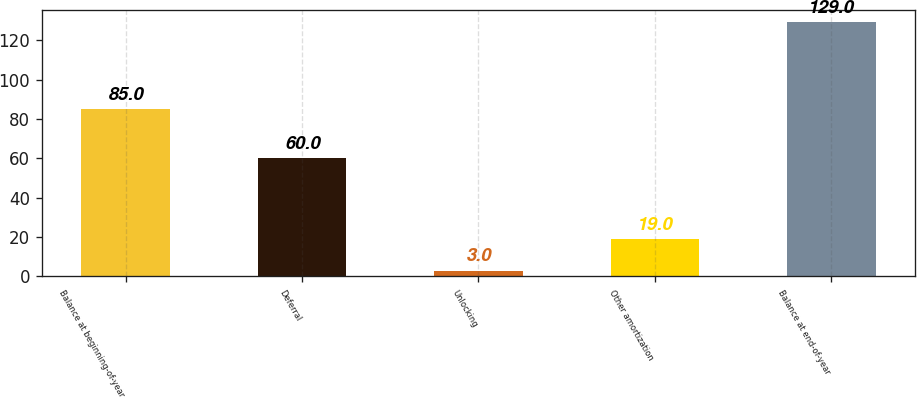<chart> <loc_0><loc_0><loc_500><loc_500><bar_chart><fcel>Balance at beginning-of-year<fcel>Deferral<fcel>Unlocking<fcel>Other amortization<fcel>Balance at end-of-year<nl><fcel>85<fcel>60<fcel>3<fcel>19<fcel>129<nl></chart> 